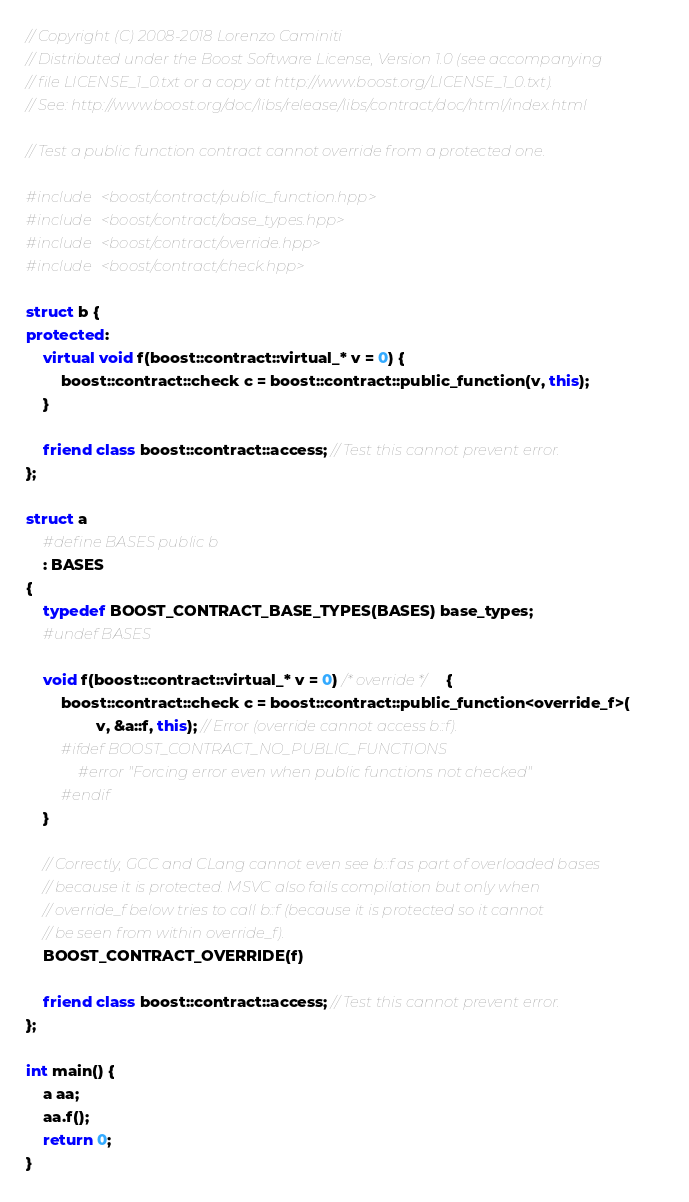Convert code to text. <code><loc_0><loc_0><loc_500><loc_500><_C++_>
// Copyright (C) 2008-2018 Lorenzo Caminiti
// Distributed under the Boost Software License, Version 1.0 (see accompanying
// file LICENSE_1_0.txt or a copy at http://www.boost.org/LICENSE_1_0.txt).
// See: http://www.boost.org/doc/libs/release/libs/contract/doc/html/index.html

// Test a public function contract cannot override from a protected one.

#include <boost/contract/public_function.hpp>
#include <boost/contract/base_types.hpp>
#include <boost/contract/override.hpp>
#include <boost/contract/check.hpp>

struct b {
protected:
    virtual void f(boost::contract::virtual_* v = 0) {
        boost::contract::check c = boost::contract::public_function(v, this);
    }
    
    friend class boost::contract::access; // Test this cannot prevent error.
};

struct a
    #define BASES public b
    : BASES
{
    typedef BOOST_CONTRACT_BASE_TYPES(BASES) base_types;
    #undef BASES

    void f(boost::contract::virtual_* v = 0) /* override */ {
        boost::contract::check c = boost::contract::public_function<override_f>(
                v, &a::f, this); // Error (override cannot access b::f).
        #ifdef BOOST_CONTRACT_NO_PUBLIC_FUNCTIONS
            #error "Forcing error even when public functions not checked"
        #endif
    }

    // Correctly, GCC and CLang cannot even see b::f as part of overloaded bases
    // because it is protected. MSVC also fails compilation but only when
    // override_f below tries to call b::f (because it is protected so it cannot
    // be seen from within override_f).
    BOOST_CONTRACT_OVERRIDE(f)
    
    friend class boost::contract::access; // Test this cannot prevent error.
};

int main() {
    a aa;
    aa.f();
    return 0;
}

</code> 